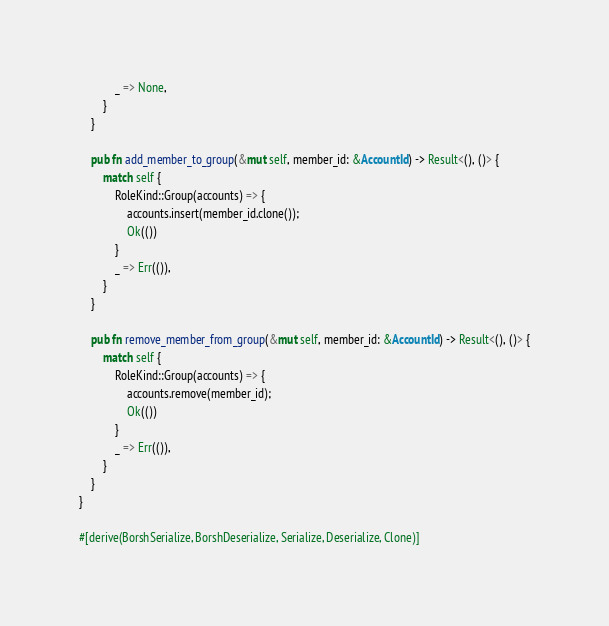Convert code to text. <code><loc_0><loc_0><loc_500><loc_500><_Rust_>            _ => None,
        }
    }

    pub fn add_member_to_group(&mut self, member_id: &AccountId) -> Result<(), ()> {
        match self {
            RoleKind::Group(accounts) => {
                accounts.insert(member_id.clone());
                Ok(())
            }
            _ => Err(()),
        }
    }

    pub fn remove_member_from_group(&mut self, member_id: &AccountId) -> Result<(), ()> {
        match self {
            RoleKind::Group(accounts) => {
                accounts.remove(member_id);
                Ok(())
            }
            _ => Err(()),
        }
    }
}

#[derive(BorshSerialize, BorshDeserialize, Serialize, Deserialize, Clone)]</code> 